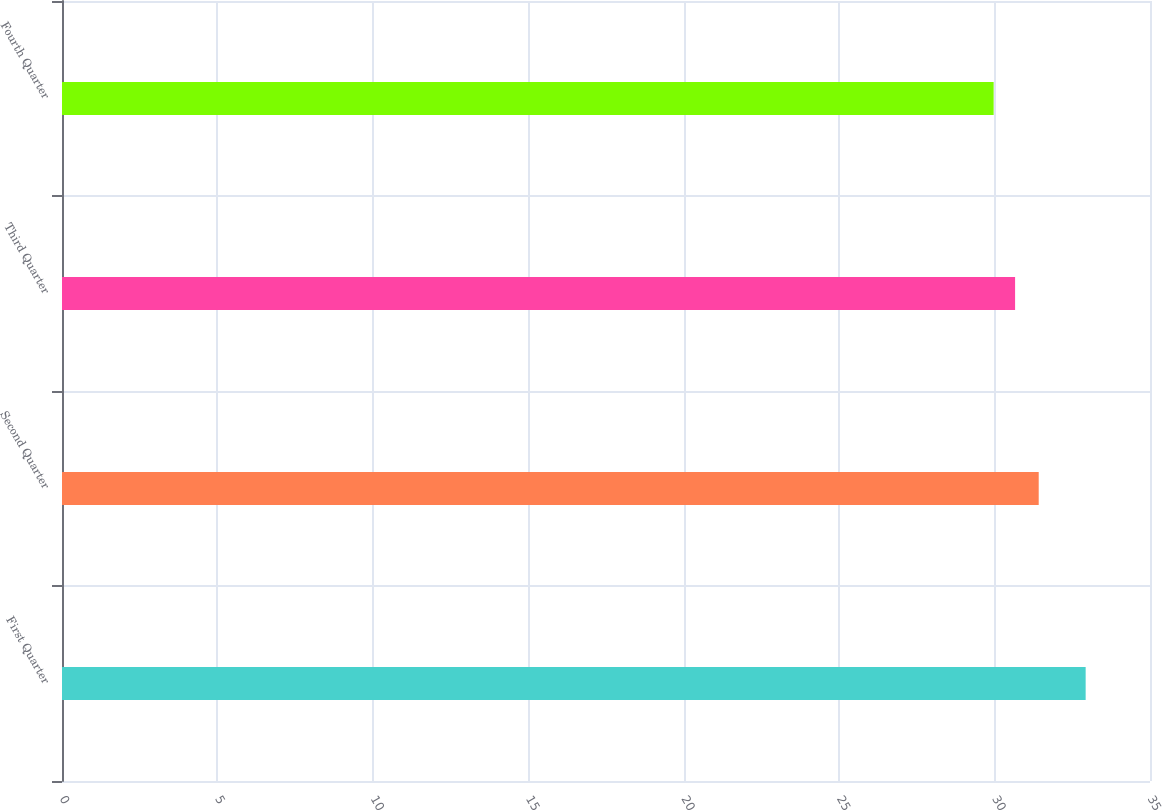Convert chart to OTSL. <chart><loc_0><loc_0><loc_500><loc_500><bar_chart><fcel>First Quarter<fcel>Second Quarter<fcel>Third Quarter<fcel>Fourth Quarter<nl><fcel>32.93<fcel>31.42<fcel>30.66<fcel>29.97<nl></chart> 